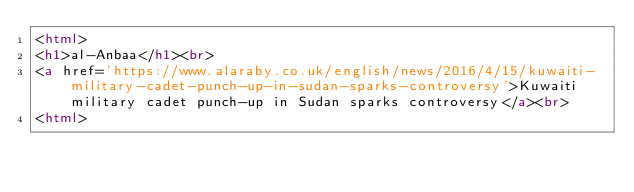Convert code to text. <code><loc_0><loc_0><loc_500><loc_500><_HTML_><html>
<h1>al-Anbaa</h1><br>
<a href='https://www.alaraby.co.uk/english/news/2016/4/15/kuwaiti-military-cadet-punch-up-in-sudan-sparks-controversy'>Kuwaiti military cadet punch-up in Sudan sparks controversy</a><br>
<html></code> 